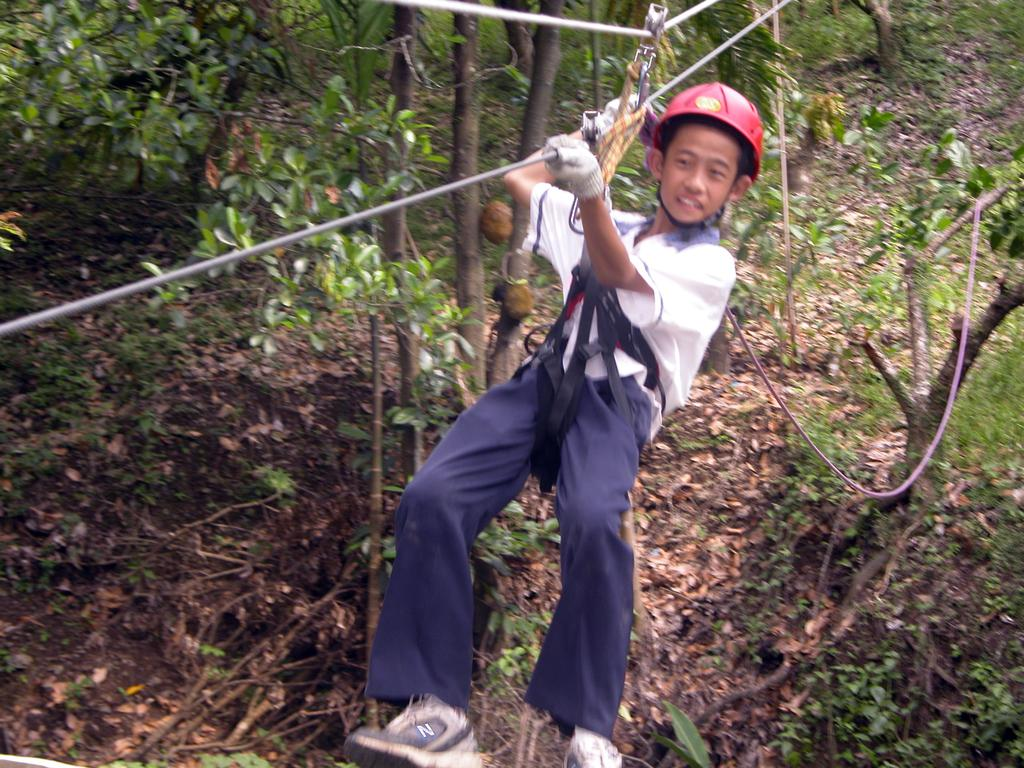What is the main subject of the image? There is a person in the image. What is the person holding in the image? The person is holding a rope. Can you describe the person's clothing in the image? The person is wearing a white shirt and blue pants. What can be seen in the background of the image? There are trees in the background of the image. What is the color of the trees in the image? The trees are green in color. What type of development can be seen in the image? There is no development visible in the image; it features a person holding a rope with trees in the background. Can you see any fish in the image? There are no fish present in the image. 